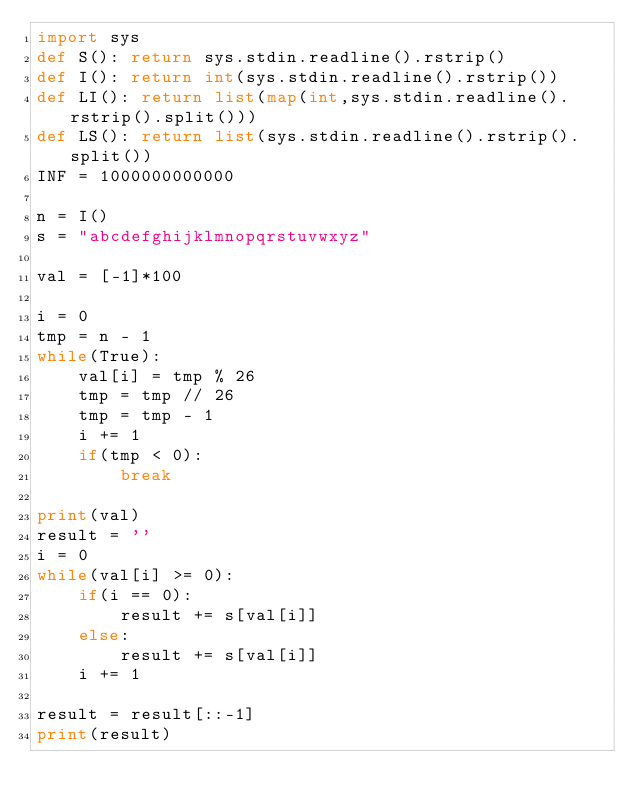<code> <loc_0><loc_0><loc_500><loc_500><_Python_>import sys
def S(): return sys.stdin.readline().rstrip()
def I(): return int(sys.stdin.readline().rstrip())
def LI(): return list(map(int,sys.stdin.readline().rstrip().split()))
def LS(): return list(sys.stdin.readline().rstrip().split())
INF = 1000000000000

n = I()
s = "abcdefghijklmnopqrstuvwxyz"

val = [-1]*100

i = 0
tmp = n - 1
while(True):
    val[i] = tmp % 26
    tmp = tmp // 26
    tmp = tmp - 1
    i += 1
    if(tmp < 0):
        break

print(val)
result = ''
i = 0
while(val[i] >= 0):
    if(i == 0):
        result += s[val[i]]
    else:
        result += s[val[i]]
    i += 1

result = result[::-1]
print(result)</code> 